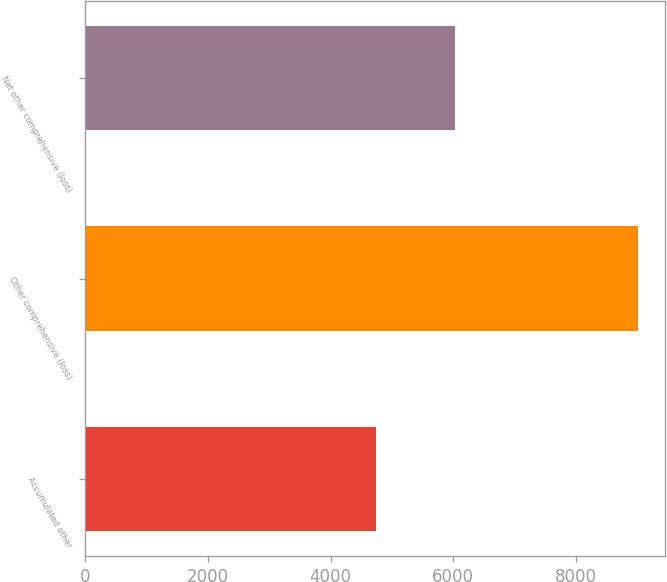<chart> <loc_0><loc_0><loc_500><loc_500><bar_chart><fcel>Accumulated other<fcel>Other comprehensive (loss)<fcel>Net other comprehensive (loss)<nl><fcel>4745<fcel>9004<fcel>6021<nl></chart> 